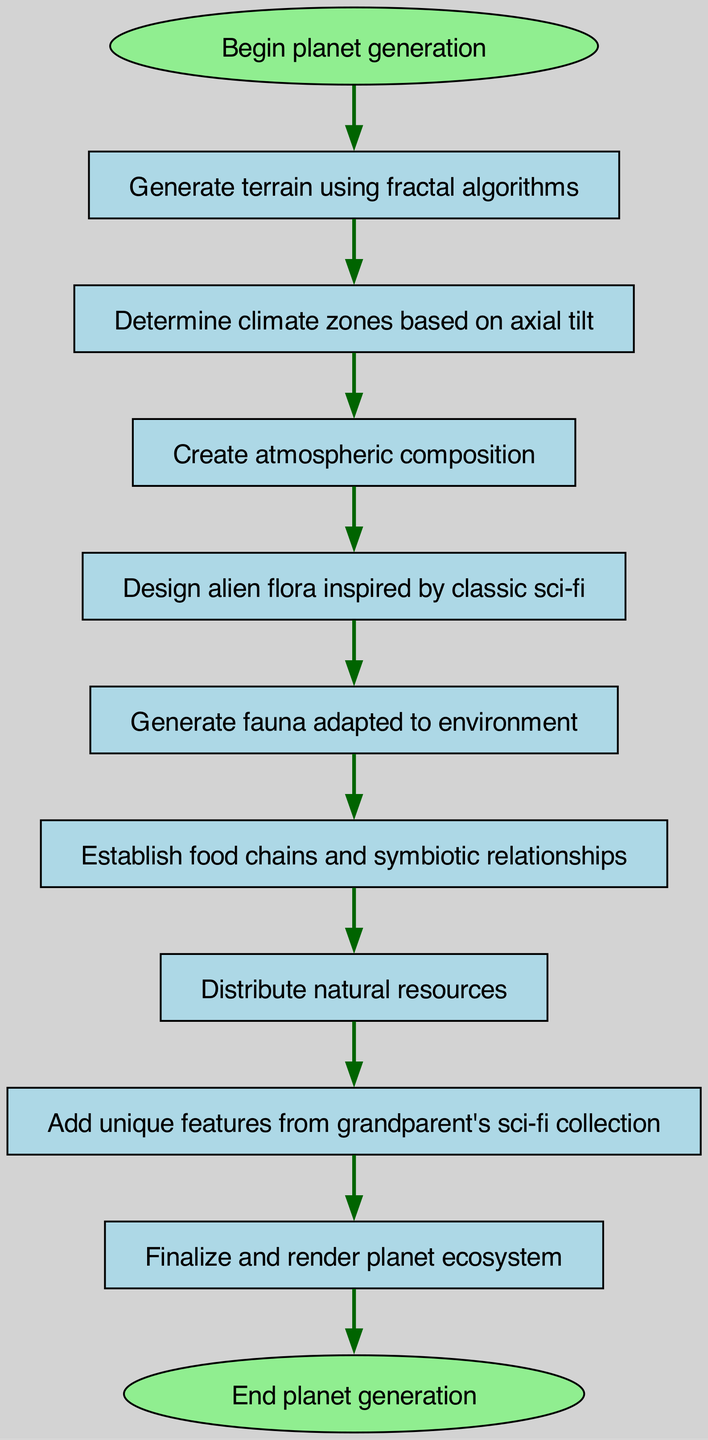What is the first step in the planet generation process? The first step identified in the diagram is "Begin planet generation," which is connected to the node labeled "terrain."
Answer: Begin planet generation How many nodes are there in total? The diagram contains 11 nodes, including the start and end nodes, each representing distinct steps in the generation process.
Answer: 11 What node follows "Generate terrain using fractal algorithms"? The node that follows "Generate terrain using fractal algorithms" is "Determine climate zones based on axial tilt," as it is directly linked in the flow.
Answer: Determine climate zones based on axial tilt Which node introduces unique features from sci-fi? The node that introduces unique features from the sci-fi collection is labeled "Add unique features from grandparent's sci-fi collection," positioned before the finalization of the planet ecosystem.
Answer: Add unique features from grandparent's sci-fi collection How many steps are there from climate to finalize? There are four steps from "Determine climate zones based on axial tilt" to "Finalize and render planet ecosystem," which are climate, atmosphere, flora, and fauna.
Answer: Four What is the last step in the process? The last step in the generation process is "End planet generation," which comes after the "Finalize and render planet ecosystem" step, marking the completion of the flowchart.
Answer: End planet generation What connects "Fauna adapted to environment" and "Establish food chains and symbiotic relationships"? The connection between "Fauna adapted to environment" and "Establish food chains and symbiotic relationships" is direct, as there is a one-way link from the fauna node to the ecosystem node showing the dependency.
Answer: One-way link How does the diagram classify "Create atmospheric composition"? The diagram classifies "Create atmospheric composition" as a sequential step following "Determine climate zones based on axial tilt," indicating it is a necessary part of the ecosystem development.
Answer: Sequential step 